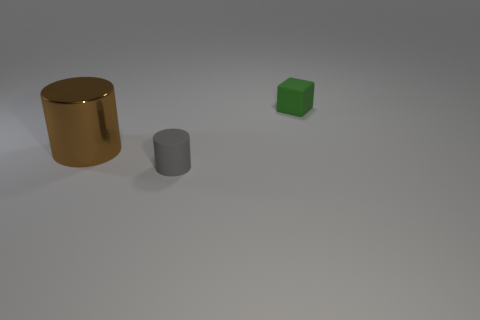Are there any other things that have the same size as the brown metal cylinder?
Your response must be concise. No. What color is the large metal thing that is the same shape as the small gray rubber object?
Make the answer very short. Brown. There is a brown thing that is the same shape as the gray object; what is its size?
Your answer should be very brief. Large. Do the small object that is to the left of the green block and the matte thing behind the big object have the same color?
Keep it short and to the point. No. There is a gray object; are there any gray rubber things in front of it?
Your answer should be compact. No. What is the big cylinder made of?
Provide a succinct answer. Metal. What is the shape of the small object that is left of the small green cube?
Offer a terse response. Cylinder. Is there a shiny thing of the same size as the green matte block?
Offer a very short reply. No. Are the cylinder that is behind the gray cylinder and the cube made of the same material?
Offer a very short reply. No. Are there the same number of cylinders behind the tiny gray matte cylinder and matte objects that are behind the large brown cylinder?
Offer a very short reply. Yes. 